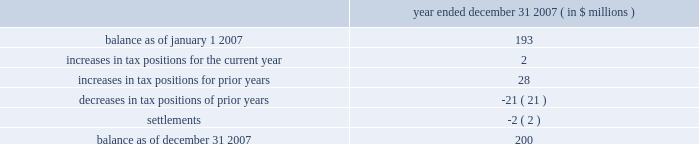Determined that it will primarily be subject to the ietu in future periods , and as such it has recorded tax expense of approximately $ 20 million in 2007 for the deferred tax effects of the new ietu system .
As of december 31 , 2007 , the company had us federal net operating loss carryforwards of approximately $ 206 million which will begin to expire in 2023 .
Of this amount , $ 47 million relates to the pre-acquisition period and is subject to limitation .
The remaining $ 159 million is subject to limitation as a result of the change in stock ownership in may 2006 .
This limitation is not expected to have a material impact on utilization of the net operating loss carryforwards .
The company also had foreign net operating loss carryforwards as of december 31 , 2007 of approximately $ 564 million for canada , germany , mexico and other foreign jurisdictions with various expiration dates .
Net operating losses in canada have various carryforward periods and began expiring in 2007 .
Net operating losses in germany have no expiration date .
Net operating losses in mexico have a ten year carryforward period and begin to expire in 2009 .
However , these losses are not available for use under the new ietu tax regulations in mexico .
As the ietu is the primary system upon which the company will be subject to tax in future periods , no deferred tax asset has been reflected in the balance sheet as of december 31 , 2007 for these income tax loss carryforwards .
The company adopted the provisions of fin 48 effective january 1 , 2007 .
Fin 48 clarifies the accounting for income taxes by prescribing a minimum recognition threshold a tax benefit is required to meet before being recognized in the financial statements .
Fin 48 also provides guidance on derecognition , measurement , classification , interest and penalties , accounting in interim periods , disclosure and transition .
As a result of the implementation of fin 48 , the company increased retained earnings by $ 14 million and decreased goodwill by $ 2 million .
In addition , certain tax liabilities for unrecognized tax benefits , as well as related potential penalties and interest , were reclassified from current liabilities to long-term liabilities .
Liabilities for unrecognized tax benefits as of december 31 , 2007 relate to various us and foreign jurisdictions .
A reconciliation of the beginning and ending amount of unrecognized tax benefits is as follows : year ended december 31 , 2007 ( in $ millions ) .
Included in the unrecognized tax benefits of $ 200 million as of december 31 , 2007 is $ 56 million of tax benefits that , if recognized , would reduce the company 2019s effective tax rate .
The company recognizes interest and penalties related to unrecognized tax benefits in the provision for income taxes .
As of december 31 , 2007 , the company has recorded a liability of approximately $ 36 million for interest and penalties .
This amount includes an increase of approximately $ 13 million for the year ended december 31 , 2007 .
The company operates in the united states ( including multiple state jurisdictions ) , germany and approximately 40 other foreign jurisdictions including canada , china , france , mexico and singapore .
Examinations are ongoing in a number of those jurisdictions including , most significantly , in germany for the years 2001 to 2004 .
During the quarter ended march 31 , 2007 , the company received final assessments in germany for the prior examination period , 1997 to 2000 .
The effective settlement of those examinations resulted in a reduction to goodwill of approximately $ 42 million with a net expected cash outlay of $ 29 million .
The company 2019s celanese corporation and subsidiaries notes to consolidated financial statements 2014 ( continued ) %%transmsg*** transmitting job : y48011 pcn : 122000000 ***%%pcmsg|f-49 |00023|yes|no|02/26/2008 22:07|0|0|page is valid , no graphics -- color : d| .
What is the percent of interest and penalties as part of the unrecognized tax benefits as of december 312007? 
Rationale: the company has recorded approximately 18% of in interest and penalties related to the 200 million unrecognized tax benefits balance as of december 312007
Computations: (36 / 2000)
Answer: 0.018. 